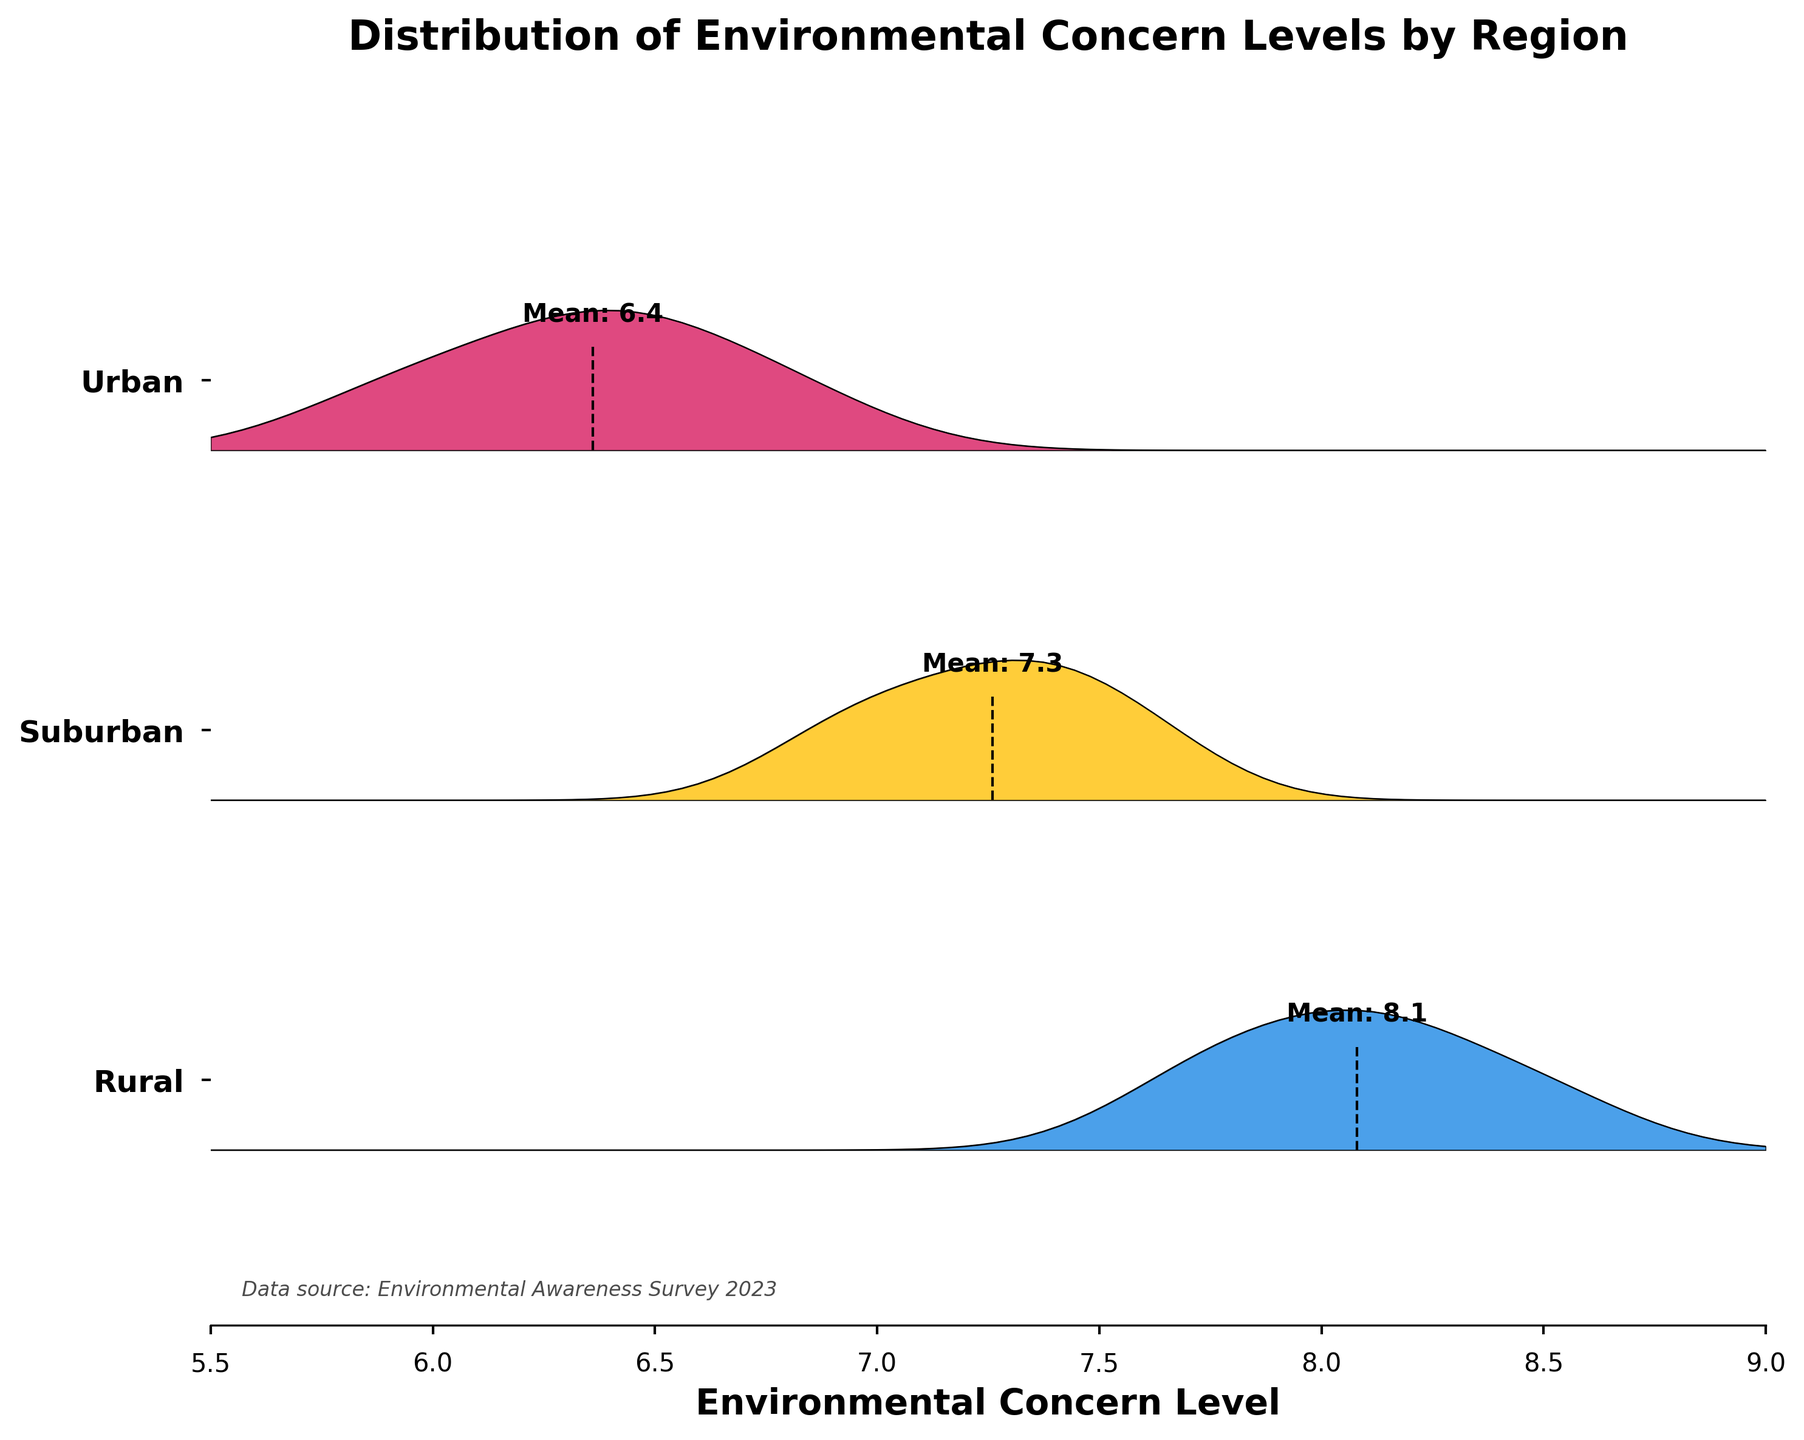What is the title of the figure? The title is written at the top of the figure. It summarizes the content and focus of the visualized data.
Answer: Distribution of Environmental Concern Levels by Region How is the x-axis labeled, and what does it represent? The x-axis label is found at the bottom of the figure, indicating what metric is being measured horizontally.
Answer: Environmental Concern Level What are the three regions represented in the figure? The y-axis tick labels indicate the three different geographical areas included in the data.
Answer: Urban, Suburban, Rural Which region has the highest average concern level, and what is the value? A vertical dashed line with a text label indicates the mean concern level for each region. The Urban region has the highest mean.
Answer: Urban, 8.1 Which region has the lowest average concern level, and what is the value? The lowest average is shown by the vertical dashed line with a textual label among all regions. Rural has the lowest mean.
Answer: Rural, 6.4 How do the distributions of concern levels differ between the Urban and Rural regions? Comparing the shapes of the filled areas indicates the spread and peaks of the concern levels for both regions. Urban has a peak spread towards higher levels, while Rural has a lower and more spread-out distribution.
Answer: Urban has higher and more concentrated values, whereas Rural has lower and more spread-out values What is the color used to represent the Suburban region, and how does it compare to the other regions? The Suburban region is marked with a specific color between the two other colored regions.
Answer: Yellow; the Urban region is blue and the Rural region is pink Which region shows the widest range of concern levels, and how can you tell? The width of the filled area along the x-axis indicates the range of concern levels.
Answer: Urban; it spans a broader range along the x-axis How do the mean concern levels compare across all three regions? The vertical dashed lines with text labels show where each region's mean is located on the x-axis. The Urban region has the highest mean, followed by Suburban, and Rural has the lowest.
Answer: Urban > Suburban > Rural What general trend can be observed regarding environmental concern levels between urban and rural populations? By looking at the overall distribution and average concern levels across regions, one can discern whether there's a gradual increase or decrease.
Answer: Urban populations generally show higher concern levels than rural populations 